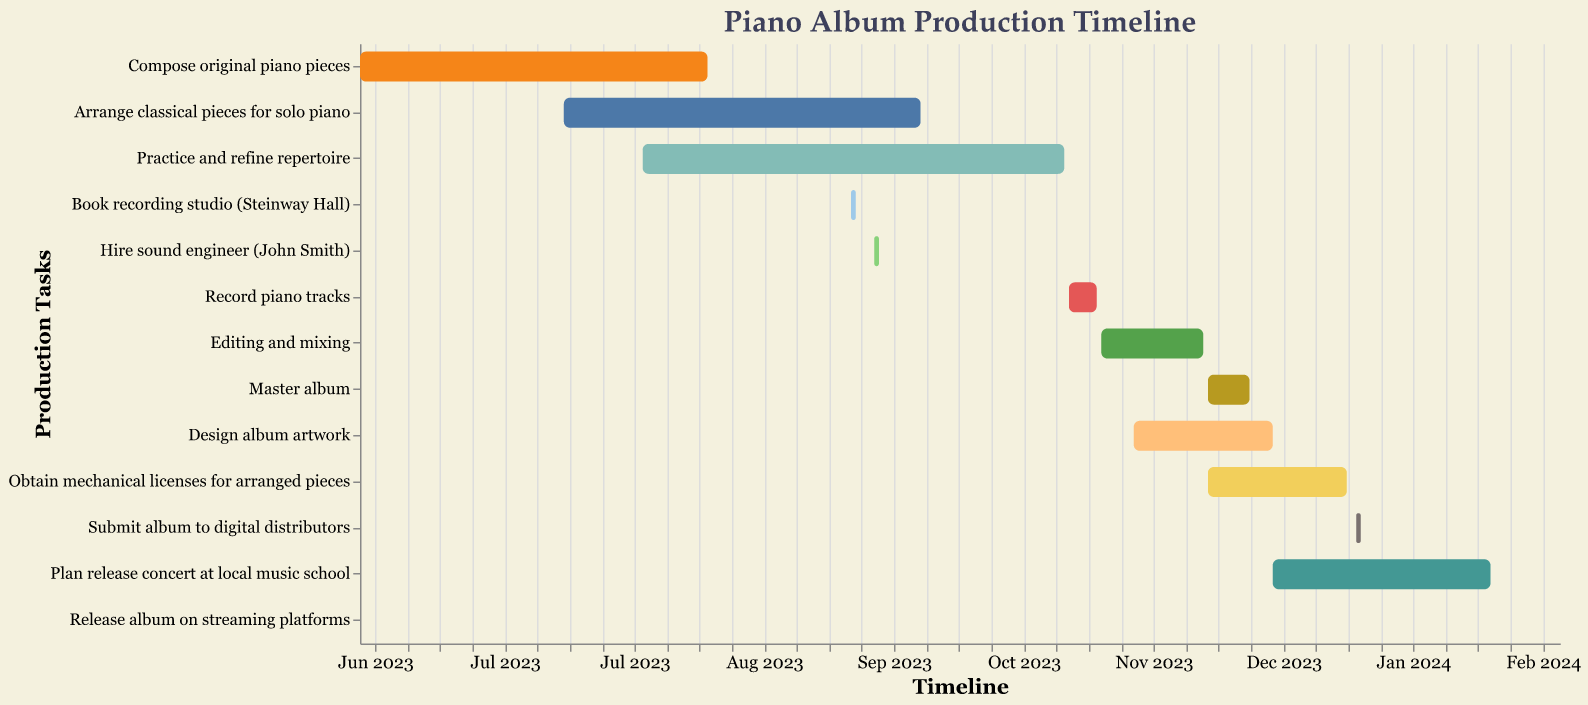What is the time span for the task "Compose original piano pieces"? Locate the task "Compose original piano pieces" in the Production Tasks column and observe the Start and End dates. The Start date is June 1, 2023, and the End date is August 15, 2023.
Answer: June 1, 2023 - August 15, 2023 How long does it take to "Record piano tracks"? Find the task "Record piano tracks" and check its Start and End dates. The task starts on November 1, 2023, and ends on November 7, 2023. Calculate the duration by counting the days inclusive.
Answer: 7 days Which task starts first in the timeline? Scan the Start dates for all tasks and identify the earliest date. The earliest Start date is June 1, 2023, for the task "Compose original piano pieces".
Answer: Compose original piano pieces How many tasks are ongoing in November 2023? Look at the timeline and count the tasks that overlap with November 2023. These tasks are "Record piano tracks", "Editing and mixing", "Master album", "Design album artwork".
Answer: 4 tasks Which task has the shortest duration, and how long is it? Compare the lengths of the bars representing the duration of each task. The shortest duration is for "Book recording studio (Steinway Hall)", which spans just one day (September 15-16, 2023).
Answer: Book recording studio (Steinway Hall), 1 day Do any of the tasks overlap in August 2023? Check the tasks' timelines to see which ones cover the month of August 2023. The tasks "Compose original piano pieces", "Arrange classical pieces for solo piano", and "Practice and refine repertoire" all overlap in August 2023.
Answer: Yes When does the task "Submit album to digital distributors" take place? Find the task "Submit album to digital distributors" and note its Start and End dates. The task takes place from January 2, 2024, to January 3, 2024.
Answer: January 2-3, 2024 Which tasks extend beyond the year 2023? Identify the tasks whose timelines extend past December 31, 2023. The tasks "Submit album to digital distributors" and "Plan release concert at local music school" both extend into 2024.
Answer: Submit album to digital distributors, Plan release concert at local music school What is the total duration from the start of the first task to the end of the last task? Determine the Start date of the first task "Compose original piano pieces" (June 1, 2023) and the End date of the last task "Release album on streaming platforms" (February 1, 2024). Calculate the time span between these two dates.
Answer: 8 months 